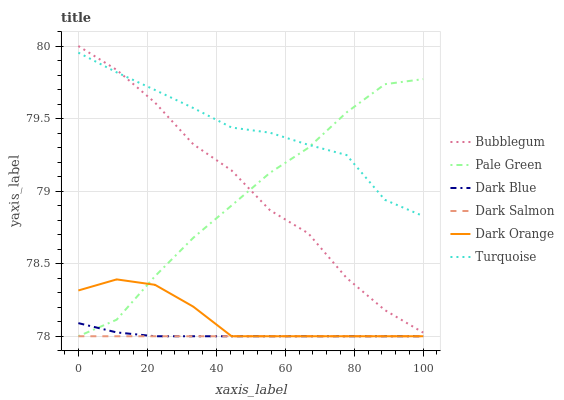Does Dark Salmon have the minimum area under the curve?
Answer yes or no. Yes. Does Turquoise have the maximum area under the curve?
Answer yes or no. Yes. Does Turquoise have the minimum area under the curve?
Answer yes or no. No. Does Dark Salmon have the maximum area under the curve?
Answer yes or no. No. Is Dark Salmon the smoothest?
Answer yes or no. Yes. Is Bubblegum the roughest?
Answer yes or no. Yes. Is Turquoise the smoothest?
Answer yes or no. No. Is Turquoise the roughest?
Answer yes or no. No. Does Turquoise have the lowest value?
Answer yes or no. No. Does Bubblegum have the highest value?
Answer yes or no. Yes. Does Turquoise have the highest value?
Answer yes or no. No. Is Dark Orange less than Turquoise?
Answer yes or no. Yes. Is Bubblegum greater than Dark Salmon?
Answer yes or no. Yes. Does Pale Green intersect Dark Blue?
Answer yes or no. Yes. Is Pale Green less than Dark Blue?
Answer yes or no. No. Is Pale Green greater than Dark Blue?
Answer yes or no. No. Does Dark Orange intersect Turquoise?
Answer yes or no. No. 